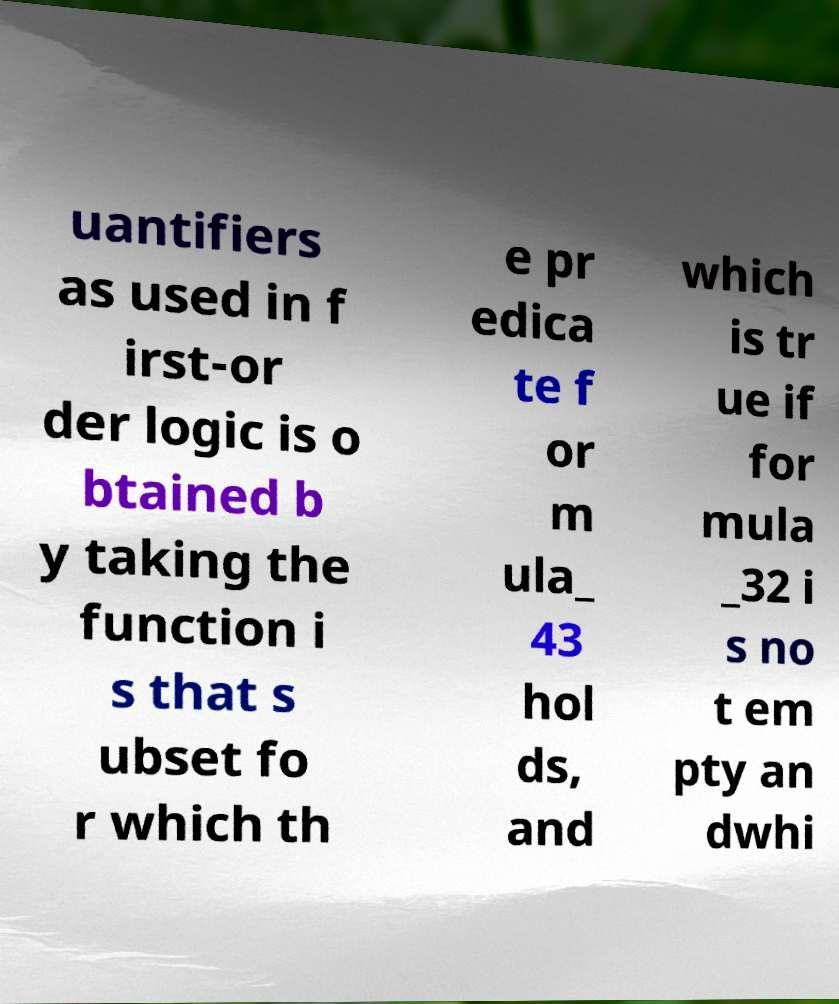For documentation purposes, I need the text within this image transcribed. Could you provide that? uantifiers as used in f irst-or der logic is o btained b y taking the function i s that s ubset fo r which th e pr edica te f or m ula_ 43 hol ds, and which is tr ue if for mula _32 i s no t em pty an dwhi 